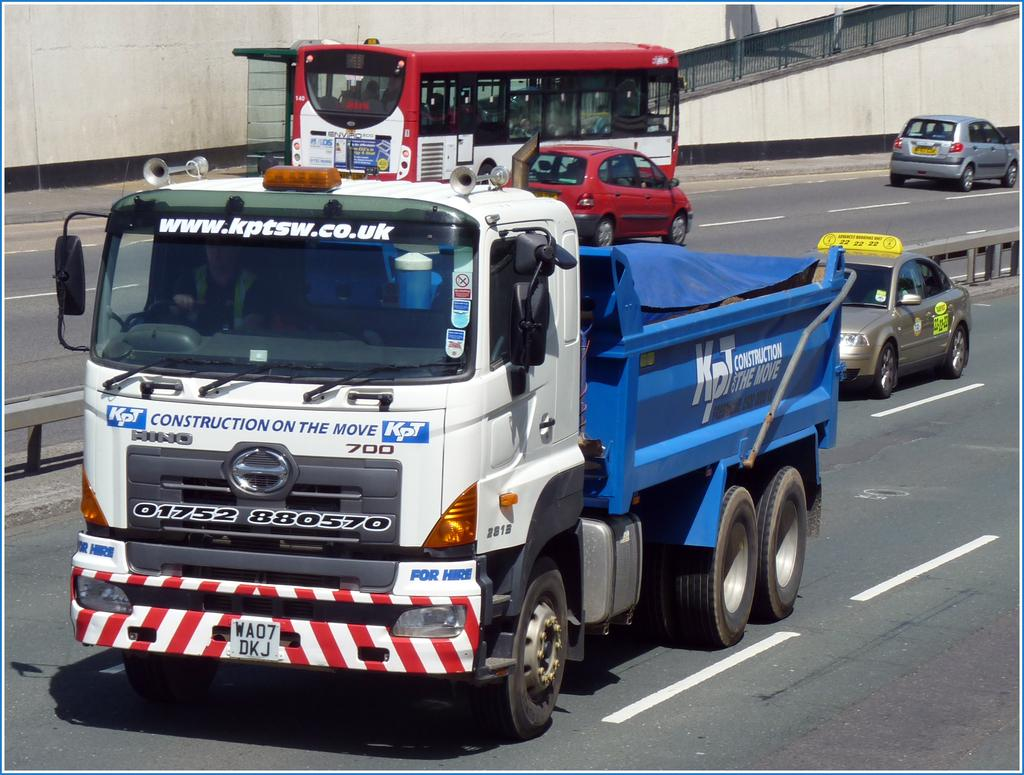<image>
Create a compact narrative representing the image presented. The dump truck is from the United Kingdom and has a blue bed 